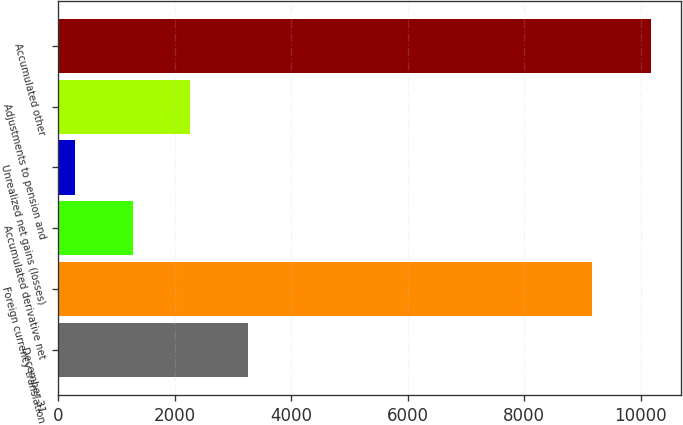Convert chart. <chart><loc_0><loc_0><loc_500><loc_500><bar_chart><fcel>December 31<fcel>Foreign currency translation<fcel>Accumulated derivative net<fcel>Unrealized net gains (losses)<fcel>Adjustments to pension and<fcel>Accumulated other<nl><fcel>3253.8<fcel>9167<fcel>1276.6<fcel>288<fcel>2265.2<fcel>10174<nl></chart> 